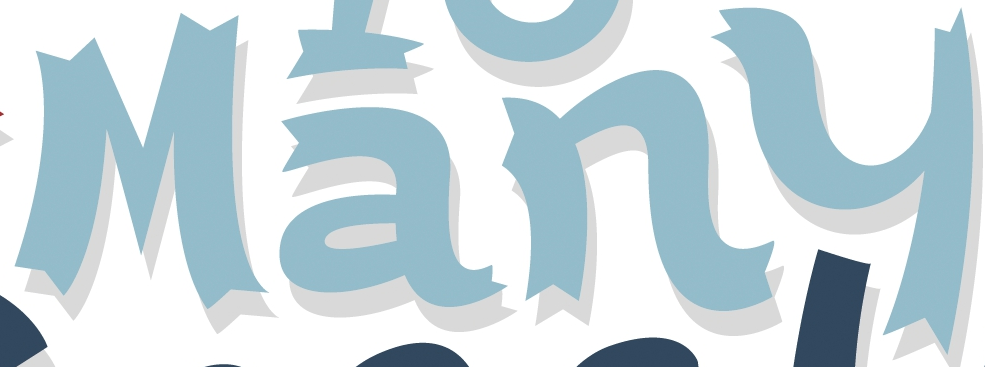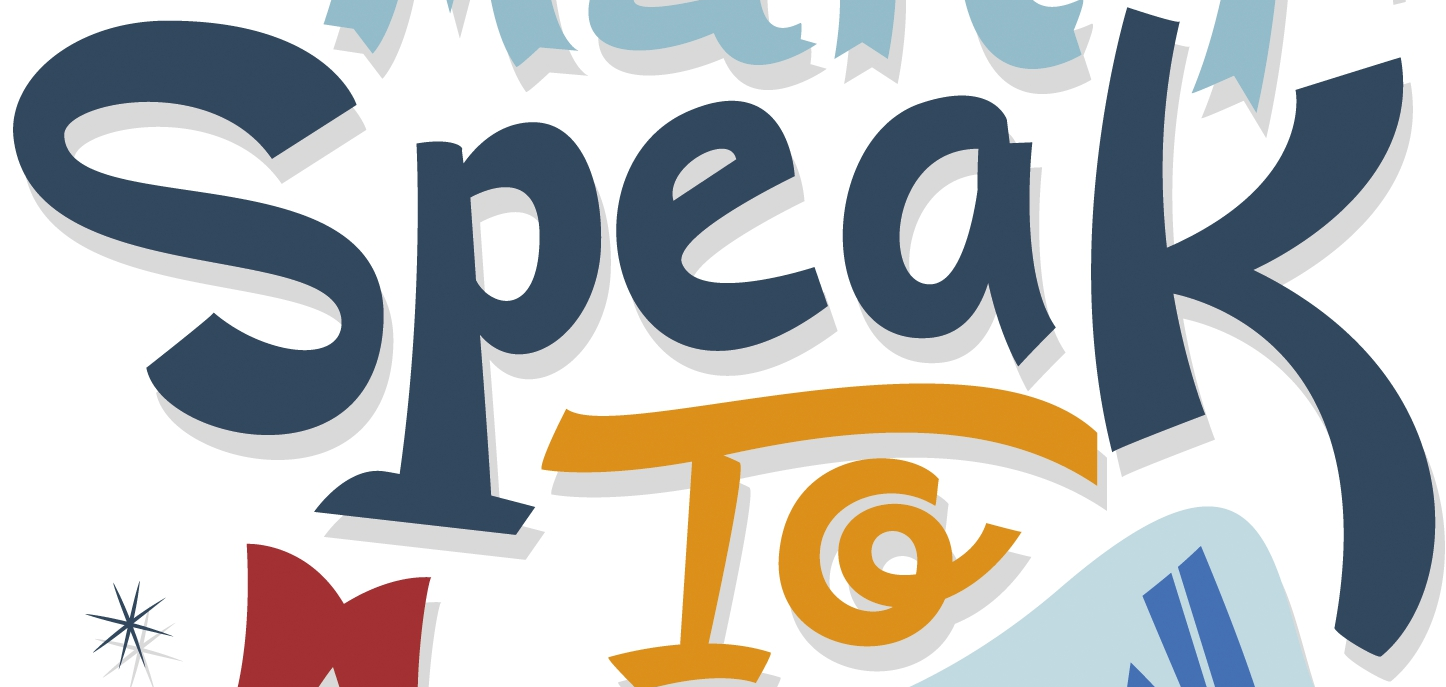What words are shown in these images in order, separated by a semicolon? Many; Speak 